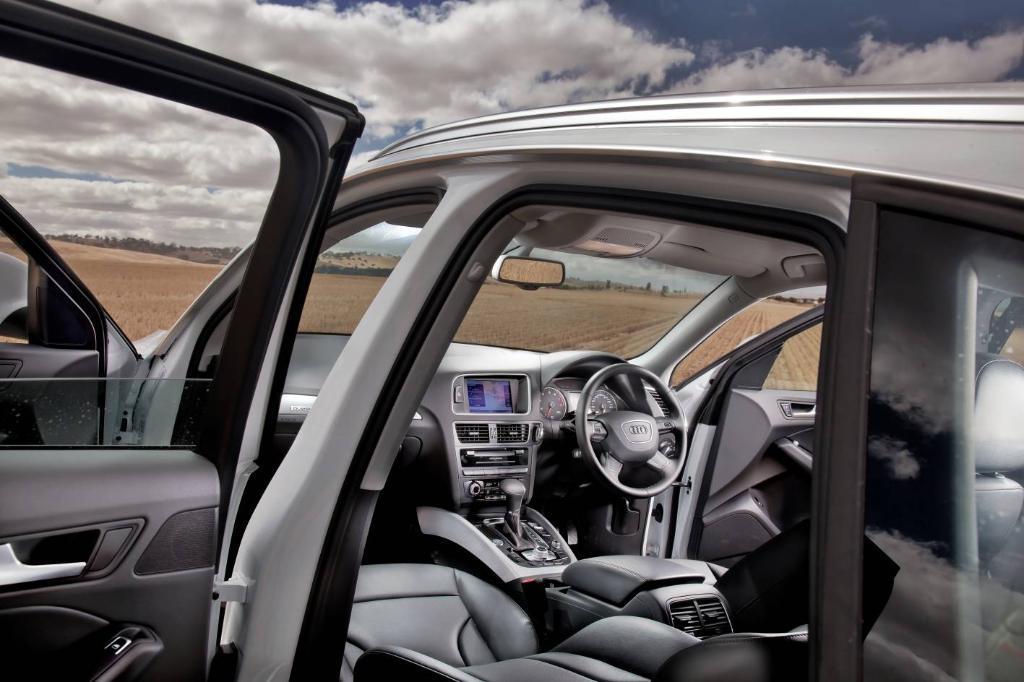Can you describe this image briefly? Picture of a vehicle. In this picture we can see steering, windshield, mirror, gear and music player. Background we can see cloudy sky. 